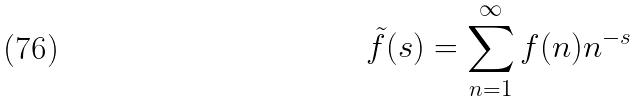Convert formula to latex. <formula><loc_0><loc_0><loc_500><loc_500>\tilde { f } ( s ) = \sum _ { n = 1 } ^ { \infty } f ( n ) n ^ { - s }</formula> 